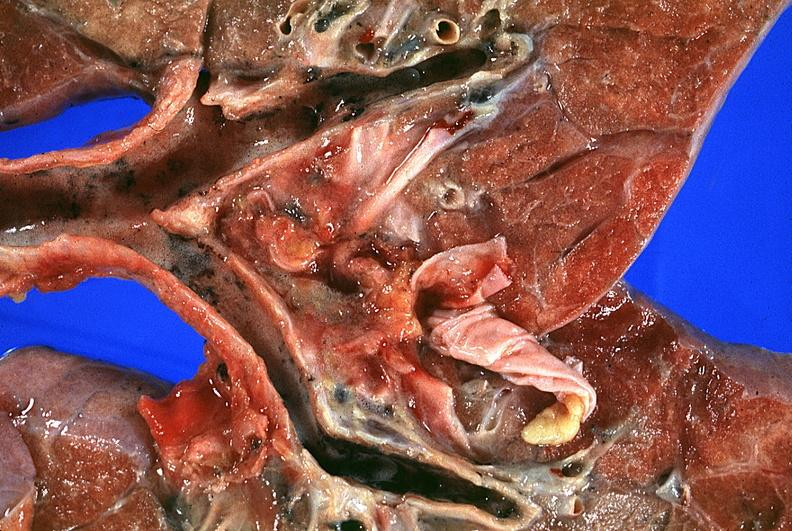do vasculature burn smoke inhalation?
Answer the question using a single word or phrase. No 